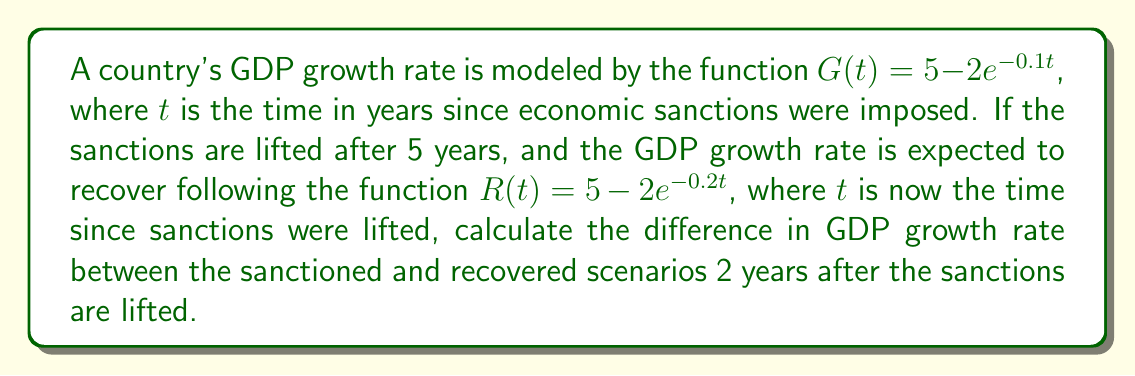Help me with this question. To solve this problem, we need to follow these steps:

1. Calculate the GDP growth rate under sanctions at t = 5 years:
   $G(5) = 5 - 2e^{-0.1(5)} = 5 - 2e^{-0.5} \approx 3.7768$

2. Calculate the GDP growth rate 2 years after sanctions are lifted:
   $R(2) = 5 - 2e^{-0.2(2)} = 5 - 2e^{-0.4} \approx 4.3297$

3. Calculate what the GDP growth rate would have been if sanctions continued for 7 years:
   $G(7) = 5 - 2e^{-0.1(7)} = 5 - 2e^{-0.7} \approx 4.0130$

4. Calculate the difference between the recovered and sanctioned scenarios:
   Difference = $R(2) - G(7) \approx 4.3297 - 4.0130 = 0.3167$
Answer: 0.3167 